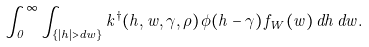<formula> <loc_0><loc_0><loc_500><loc_500>\int _ { 0 } ^ { \infty } \int _ { \{ | h | > d w \} } k ^ { \dag } ( h , w , \gamma , \rho ) \, \phi ( h - \gamma ) \, f _ { W } ( w ) \, d h \, d w .</formula> 